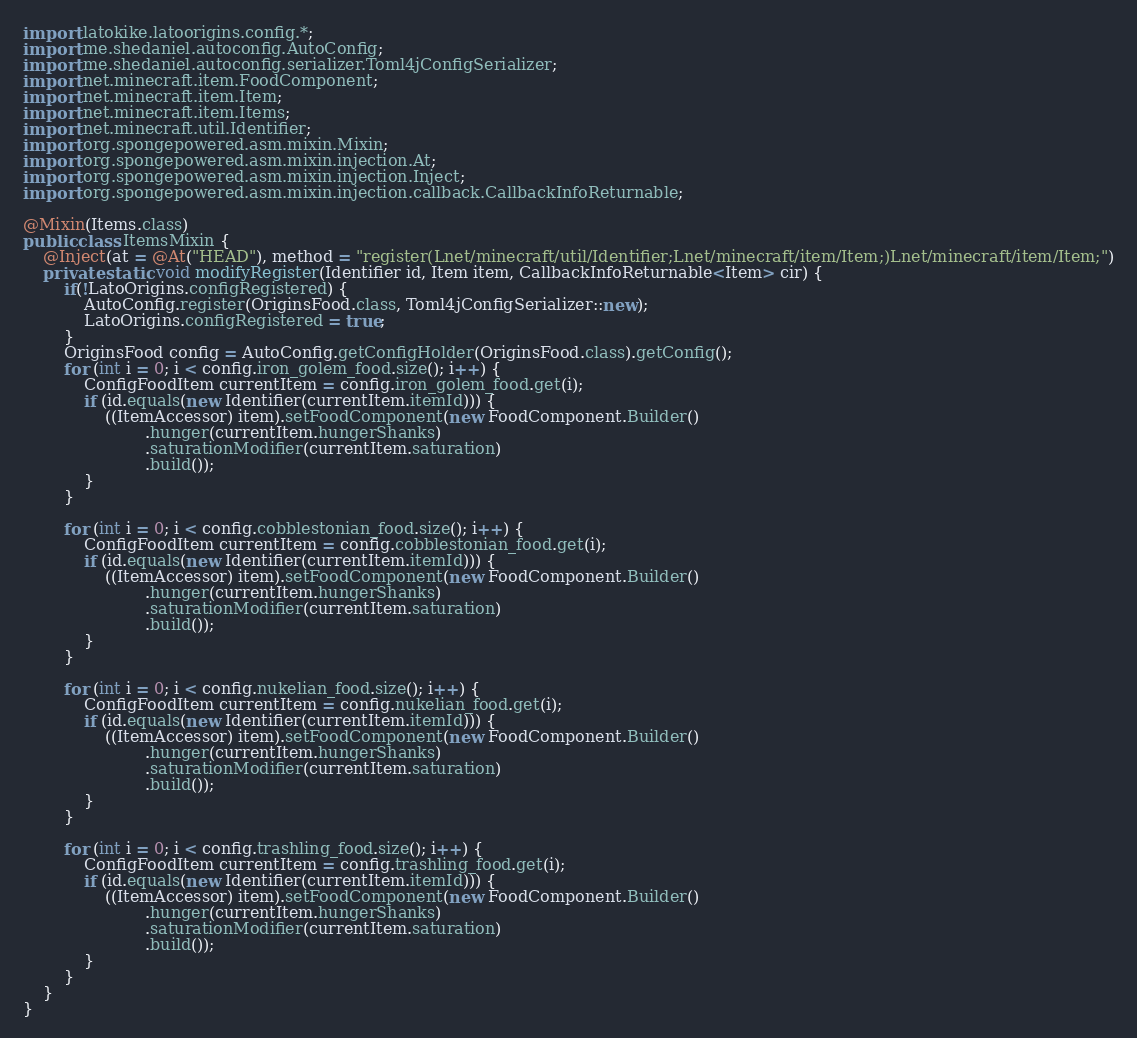Convert code to text. <code><loc_0><loc_0><loc_500><loc_500><_Java_>import latokike.latoorigins.config.*;
import me.shedaniel.autoconfig.AutoConfig;
import me.shedaniel.autoconfig.serializer.Toml4jConfigSerializer;
import net.minecraft.item.FoodComponent;
import net.minecraft.item.Item;
import net.minecraft.item.Items;
import net.minecraft.util.Identifier;
import org.spongepowered.asm.mixin.Mixin;
import org.spongepowered.asm.mixin.injection.At;
import org.spongepowered.asm.mixin.injection.Inject;
import org.spongepowered.asm.mixin.injection.callback.CallbackInfoReturnable;

@Mixin(Items.class)
public class ItemsMixin {
    @Inject(at = @At("HEAD"), method = "register(Lnet/minecraft/util/Identifier;Lnet/minecraft/item/Item;)Lnet/minecraft/item/Item;")
    private static void modifyRegister(Identifier id, Item item, CallbackInfoReturnable<Item> cir) {
        if(!LatoOrigins.configRegistered) {
            AutoConfig.register(OriginsFood.class, Toml4jConfigSerializer::new);
            LatoOrigins.configRegistered = true;
        }
        OriginsFood config = AutoConfig.getConfigHolder(OriginsFood.class).getConfig();
        for (int i = 0; i < config.iron_golem_food.size(); i++) {
            ConfigFoodItem currentItem = config.iron_golem_food.get(i);
            if (id.equals(new Identifier(currentItem.itemId))) {
                ((ItemAccessor) item).setFoodComponent(new FoodComponent.Builder()
                        .hunger(currentItem.hungerShanks)
                        .saturationModifier(currentItem.saturation)
                        .build());
            }
        }

        for (int i = 0; i < config.cobblestonian_food.size(); i++) {
            ConfigFoodItem currentItem = config.cobblestonian_food.get(i);
            if (id.equals(new Identifier(currentItem.itemId))) {
                ((ItemAccessor) item).setFoodComponent(new FoodComponent.Builder()
                        .hunger(currentItem.hungerShanks)
                        .saturationModifier(currentItem.saturation)
                        .build());
            }
        }

        for (int i = 0; i < config.nukelian_food.size(); i++) {
            ConfigFoodItem currentItem = config.nukelian_food.get(i);
            if (id.equals(new Identifier(currentItem.itemId))) {
                ((ItemAccessor) item).setFoodComponent(new FoodComponent.Builder()
                        .hunger(currentItem.hungerShanks)
                        .saturationModifier(currentItem.saturation)
                        .build());
            }
        }

        for (int i = 0; i < config.trashling_food.size(); i++) {
            ConfigFoodItem currentItem = config.trashling_food.get(i);
            if (id.equals(new Identifier(currentItem.itemId))) {
                ((ItemAccessor) item).setFoodComponent(new FoodComponent.Builder()
                        .hunger(currentItem.hungerShanks)
                        .saturationModifier(currentItem.saturation)
                        .build());
            }
        }
    }
}
</code> 